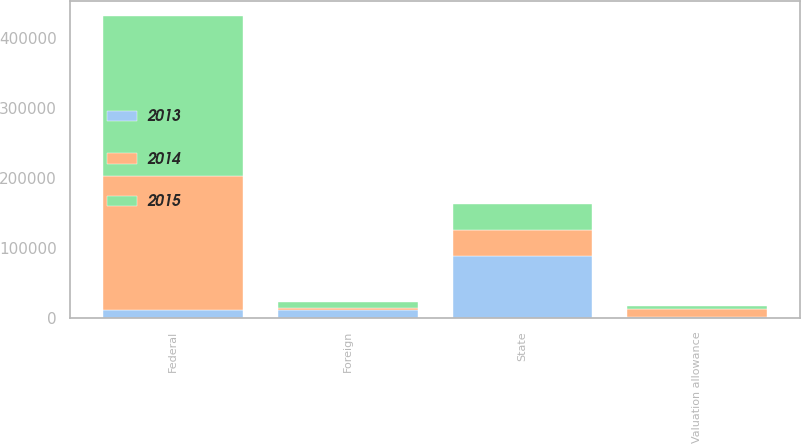<chart> <loc_0><loc_0><loc_500><loc_500><stacked_bar_chart><ecel><fcel>Federal<fcel>State<fcel>Foreign<fcel>Valuation allowance<nl><fcel>2013<fcel>11501<fcel>88671<fcel>10634<fcel>1220<nl><fcel>2015<fcel>228348<fcel>36633<fcel>7467<fcel>4406<nl><fcel>2014<fcel>191596<fcel>36662<fcel>4052<fcel>11501<nl></chart> 